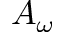Convert formula to latex. <formula><loc_0><loc_0><loc_500><loc_500>A _ { \omega }</formula> 